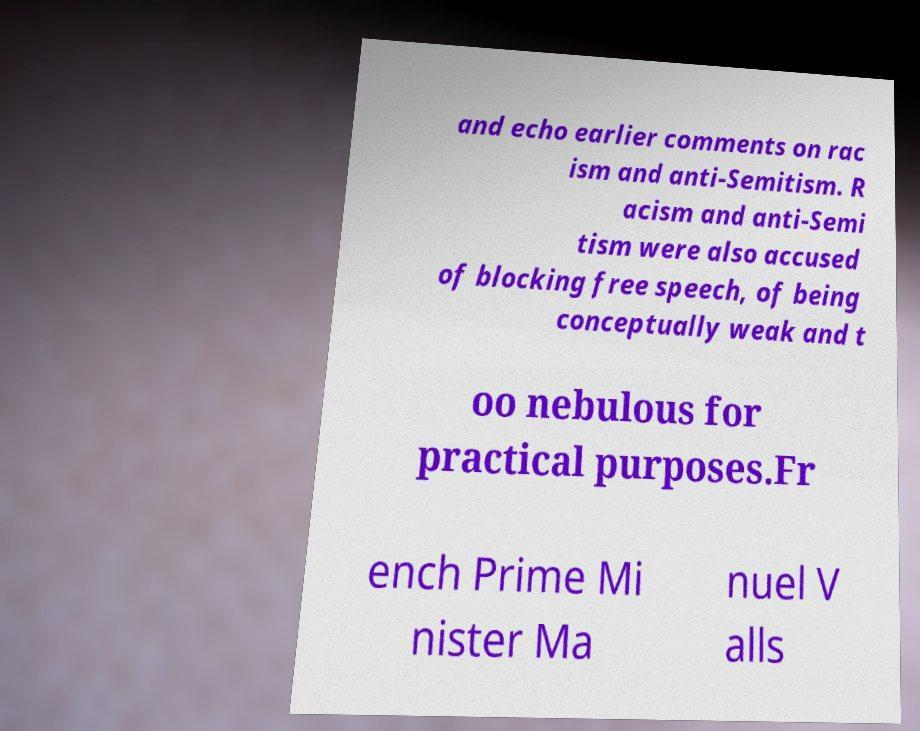I need the written content from this picture converted into text. Can you do that? and echo earlier comments on rac ism and anti-Semitism. R acism and anti-Semi tism were also accused of blocking free speech, of being conceptually weak and t oo nebulous for practical purposes.Fr ench Prime Mi nister Ma nuel V alls 